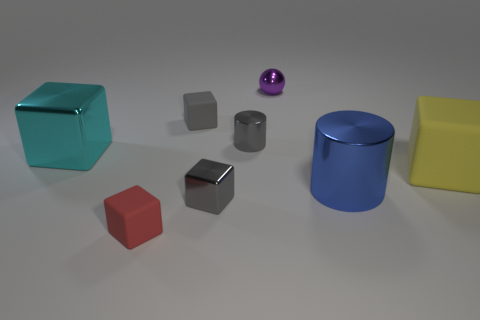What kind of materials do the objects seem to be made of? The objects appear to showcase a variety of materials. The teal and red cubes, along with the yellow prism, seem to have a matte finish, suggestive of a plastic or painted wood texture. The blue cylinder has a slightly reflective surface indicating a metallic paint finish. The small gray block and the tiny block behind it exhibit a metallic sheen, hinting at a possible metal construction, while the purple sphere has a high-gloss finish that could suggest a glass or polished metal material. 